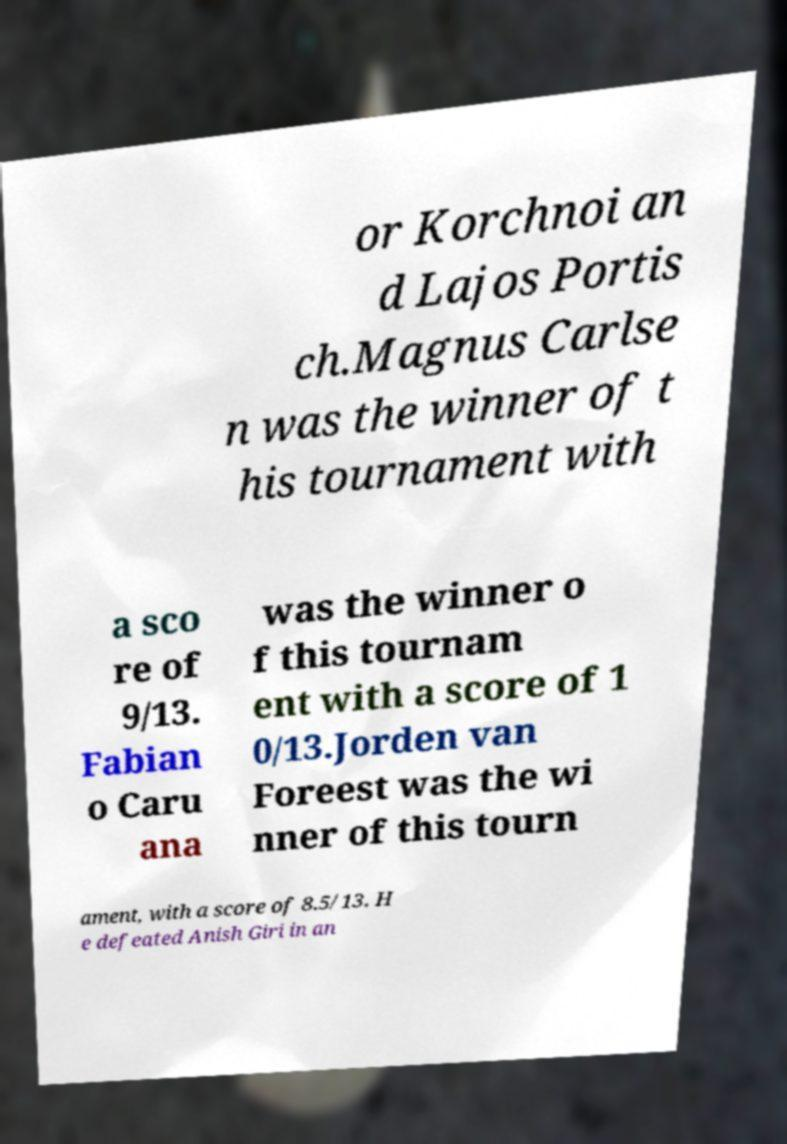What messages or text are displayed in this image? I need them in a readable, typed format. or Korchnoi an d Lajos Portis ch.Magnus Carlse n was the winner of t his tournament with a sco re of 9/13. Fabian o Caru ana was the winner o f this tournam ent with a score of 1 0/13.Jorden van Foreest was the wi nner of this tourn ament, with a score of 8.5/13. H e defeated Anish Giri in an 